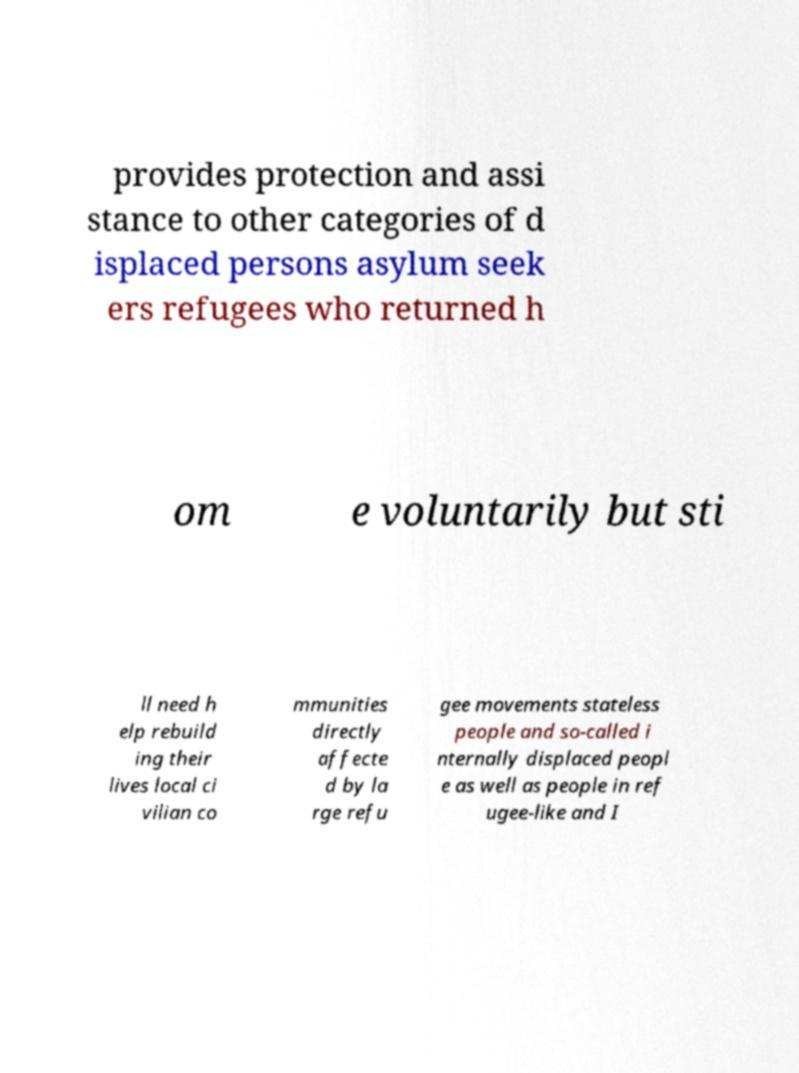Can you read and provide the text displayed in the image?This photo seems to have some interesting text. Can you extract and type it out for me? provides protection and assi stance to other categories of d isplaced persons asylum seek ers refugees who returned h om e voluntarily but sti ll need h elp rebuild ing their lives local ci vilian co mmunities directly affecte d by la rge refu gee movements stateless people and so-called i nternally displaced peopl e as well as people in ref ugee-like and I 